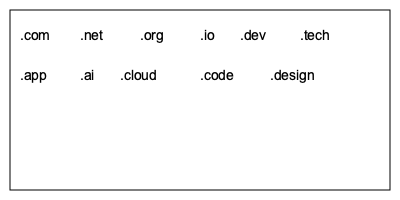Given a rectangular website footer with dimensions 380x180 pixels, how can you arrange the following domain name suffixes to maximize space usage while ensuring readability: .com, .net, .org, .io, .dev, .tech, .app, .ai, .cloud, .code, .design? What is the maximum number of rows that can be used while maintaining a minimum font size of 14px and a 20px margin on all sides? To solve this problem, we'll follow these steps:

1. Calculate the available space:
   Width: 380px - 2 * 20px (margins) = 340px
   Height: 180px - 2 * 20px (margins) = 140px

2. Determine the space needed for each suffix:
   Assuming a 14px font size, each character is approximately 8px wide.
   Add 20px spacing between suffixes.

   .com (3 chars): 3 * 8 + 20 = 44px
   .net (3 chars): 3 * 8 + 20 = 44px
   .org (3 chars): 3 * 8 + 20 = 44px
   .io (2 chars): 2 * 8 + 20 = 36px
   .dev (3 chars): 3 * 8 + 20 = 44px
   .tech (4 chars): 4 * 8 + 20 = 52px
   .app (3 chars): 3 * 8 + 20 = 44px
   .ai (2 chars): 2 * 8 + 20 = 36px
   .cloud (5 chars): 5 * 8 + 20 = 60px
   .code (4 chars): 4 * 8 + 20 = 52px
   .design (6 chars): 6 * 8 + 20 = 68px

3. Arrange suffixes in rows:
   Row 1: .com + .net + .org + .io + .dev + .tech = 264px
   Row 2: .app + .ai + .cloud + .code + .design = 260px

4. Calculate row height:
   Font size (14px) + Vertical spacing (10px) = 24px per row

5. Determine maximum number of rows:
   Available height / Row height = 140px / 24px = 5.83

Therefore, we can fit up to 5 rows while maintaining readability and the given constraints.
Answer: 5 rows 